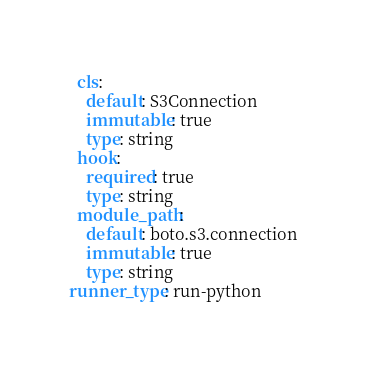<code> <loc_0><loc_0><loc_500><loc_500><_YAML_>  cls:
    default: S3Connection
    immutable: true
    type: string
  hook:
    required: true
    type: string
  module_path:
    default: boto.s3.connection
    immutable: true
    type: string
runner_type: run-python
</code> 